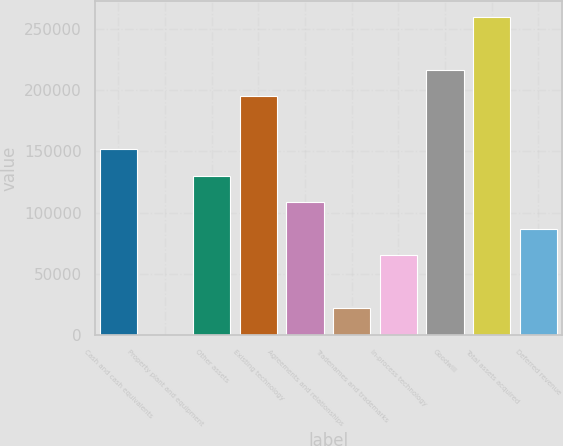Convert chart to OTSL. <chart><loc_0><loc_0><loc_500><loc_500><bar_chart><fcel>Cash and cash equivalents<fcel>Property plant and equipment<fcel>Other assets<fcel>Existing technology<fcel>Agreements and relationships<fcel>Tradenames and trademarks<fcel>In-process technology<fcel>Goodwill<fcel>Total assets acquired<fcel>Deferred revenue<nl><fcel>151586<fcel>520<fcel>130005<fcel>194747<fcel>108424<fcel>22100.8<fcel>65262.4<fcel>216328<fcel>259490<fcel>86843.2<nl></chart> 